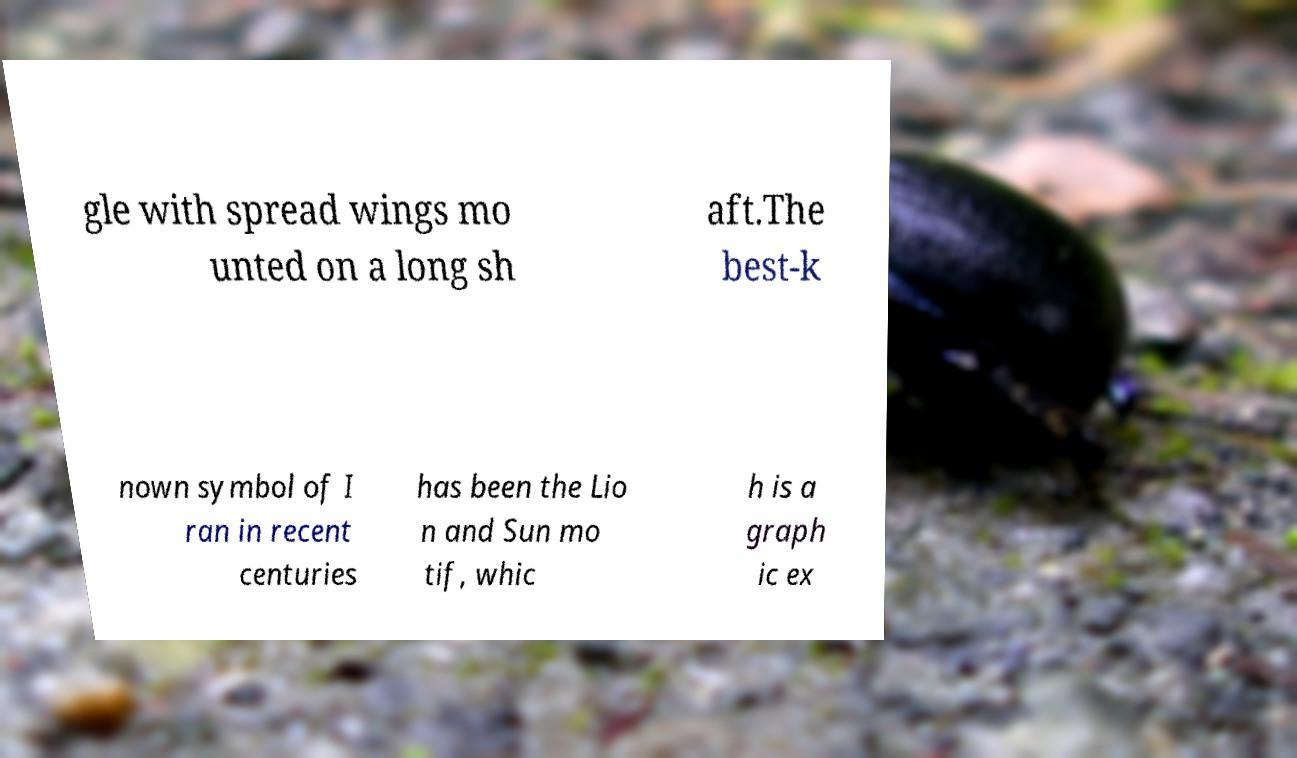Can you accurately transcribe the text from the provided image for me? gle with spread wings mo unted on a long sh aft.The best-k nown symbol of I ran in recent centuries has been the Lio n and Sun mo tif, whic h is a graph ic ex 